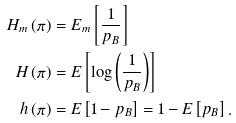<formula> <loc_0><loc_0><loc_500><loc_500>H _ { m } \left ( \pi \right ) & = E _ { m } \left [ \frac { 1 } { p _ { B } } \right ] \\ H \left ( \pi \right ) & = E \left [ \log \left ( \frac { 1 } { p _ { B } } \right ) \right ] \\ h \left ( \pi \right ) & = E \left [ 1 - p _ { B } \right ] = 1 - E \left [ p _ { B } \right ] .</formula> 